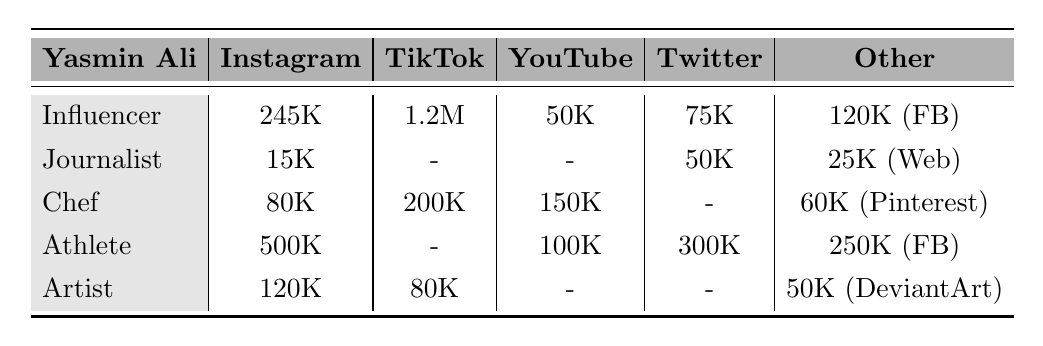What is the total number of Instagram followers across all Yasmin Alis featured? Adding the Instagram followers: 245000 (Influencer) + 15000 (Journalist) + 80000 (Chef) + 500000 (Athlete) + 120000 (Artist) = 745000
Answer: 745000 Which Yasmin Ali has the highest TikTok follower count? The Influencer has 1200000 followers and the Chef has 200000 followers; the Influencer has the most.
Answer: Influencer Does the Journalist have any TikTok followers? The table indicates that the Journalist has "-" for TikTok, meaning there are no TikTok followers.
Answer: No What is the difference in YouTube subscribers between the Chef and the Athlete? The Chef has 150000 YouTube subscribers and the Athlete has 100000; the difference is 150000 - 100000 = 50000.
Answer: 50000 How many total Facebook likes do the Athlete and the Chef have combined? The Athlete has 250000 likes, and the Chef has 35000 likes, so the total is 250000 + 35000 = 285000.
Answer: 285000 Is there a Yasmin Ali with LinkedIn connections? The table shows that only the Journalist has LinkedIn connections listed as 8000.
Answer: Yes What is the average number of Instagram followers among all Yasmin Alis? There are 5 Yasmin Alis: 245000 + 15000 + 80000 + 500000 + 120000 = 745000. The average is 745000/5 = 149000.
Answer: 149000 Which Yasmin Ali has the lowest Medium followers count? The Journalist has 3000 Medium followers, which is the lowest compared to others with no Medium listed.
Answer: Journalist What is the combined number of total followers on TikTok and Instagram for the Chef and the Artist? The Chef has 200000 TikTok followers and 80000 Instagram followers, total 200000 + 80000 = 280000; the Artist has 80000 TikTok followers and 120000 Instagram followers, total 80000 + 120000 = 200000. Combined: 280000 + 200000 = 480000.
Answer: 480000 Which Yasmin Ali has the most diverse social media presence (more platforms listed)? The Athlete has presence on four platforms: Instagram, YouTube, Facebook, and Twitter, which is more than others.
Answer: Athlete 